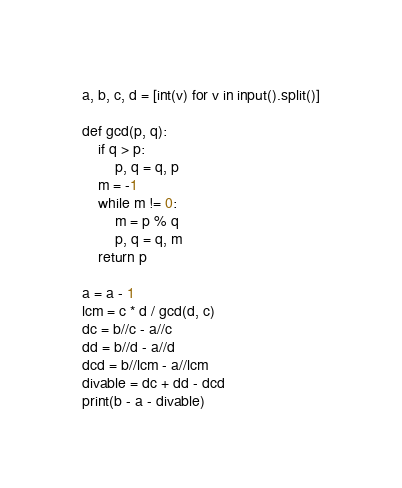Convert code to text. <code><loc_0><loc_0><loc_500><loc_500><_Python_>a, b, c, d = [int(v) for v in input().split()]

def gcd(p, q):
    if q > p:
        p, q = q, p
    m = -1
    while m != 0:
        m = p % q
        p, q = q, m
    return p

a = a - 1
lcm = c * d / gcd(d, c)
dc = b//c - a//c
dd = b//d - a//d
dcd = b//lcm - a//lcm
divable = dc + dd - dcd
print(b - a - divable)</code> 